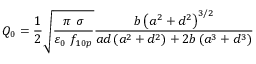Convert formula to latex. <formula><loc_0><loc_0><loc_500><loc_500>Q _ { 0 } = \frac { 1 } { 2 } \sqrt { \frac { \pi \ \sigma } { \varepsilon _ { 0 } \ f _ { 1 0 p } } } \frac { b \left ( a ^ { 2 } + d ^ { 2 } \right ) ^ { 3 / 2 } } { a d \left ( a ^ { 2 } + d ^ { 2 } \right ) + 2 b \left ( a ^ { 3 } + d ^ { 3 } \right ) }</formula> 